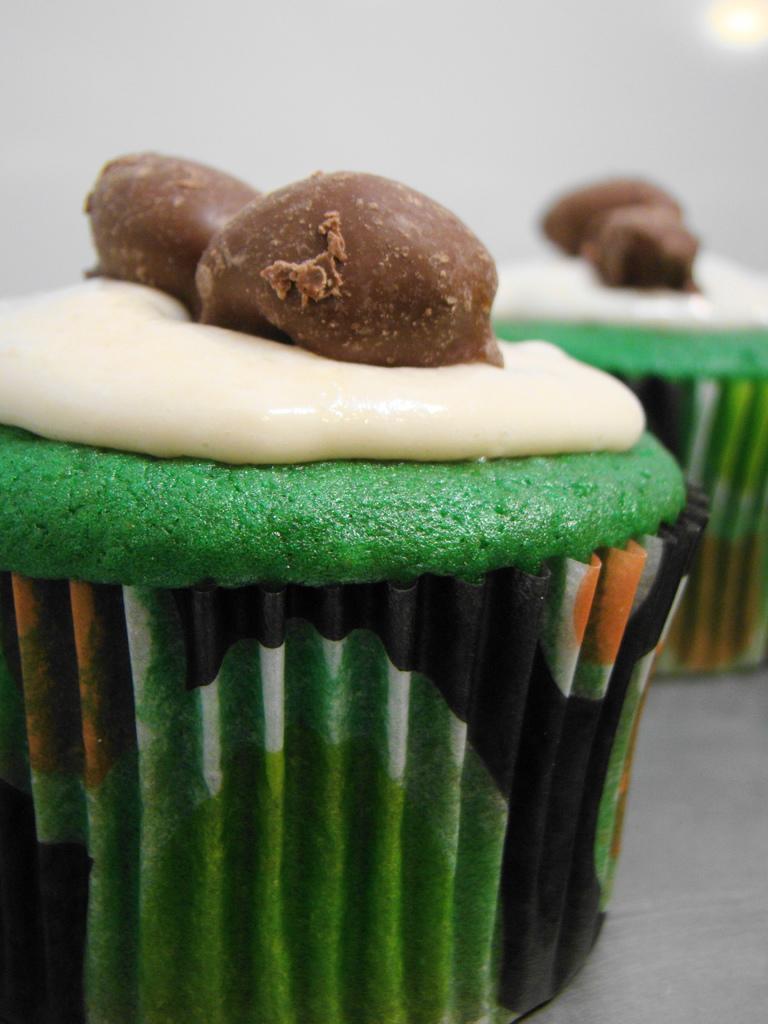Describe this image in one or two sentences. In the picture I can see the cupcakes. 